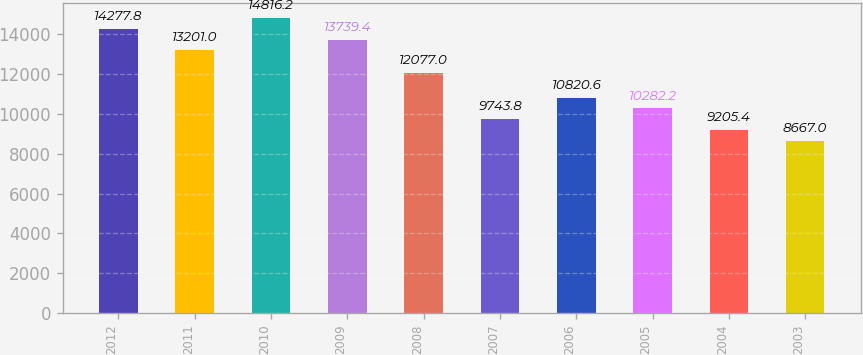Convert chart. <chart><loc_0><loc_0><loc_500><loc_500><bar_chart><fcel>2012<fcel>2011<fcel>2010<fcel>2009<fcel>2008<fcel>2007<fcel>2006<fcel>2005<fcel>2004<fcel>2003<nl><fcel>14277.8<fcel>13201<fcel>14816.2<fcel>13739.4<fcel>12077<fcel>9743.8<fcel>10820.6<fcel>10282.2<fcel>9205.4<fcel>8667<nl></chart> 